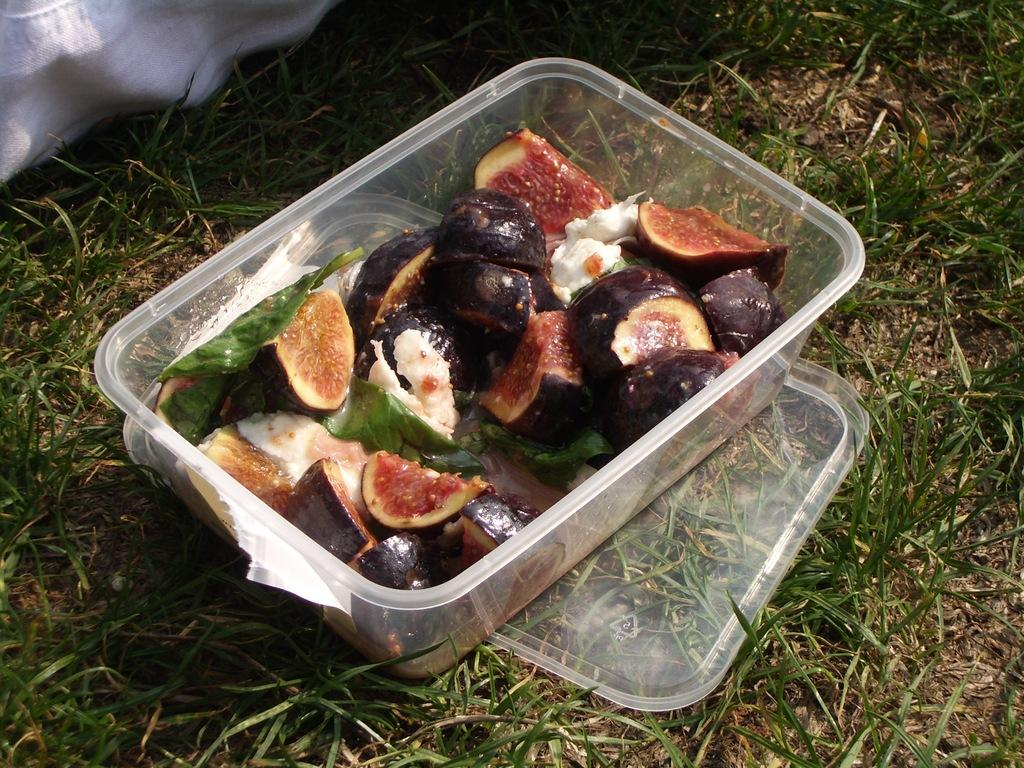What is inside the box that is visible in the image? There is food in a box in the image. Where is the box located in relation to other objects or surfaces? The box is placed on a surface. What type of natural environment can be seen around the box? There is grass visible around the box. What type of jam is being cooked in the image? There is no jam or cooking activity present in the image. How many mice can be seen interacting with the food in the box? There are no mice present in the image. 